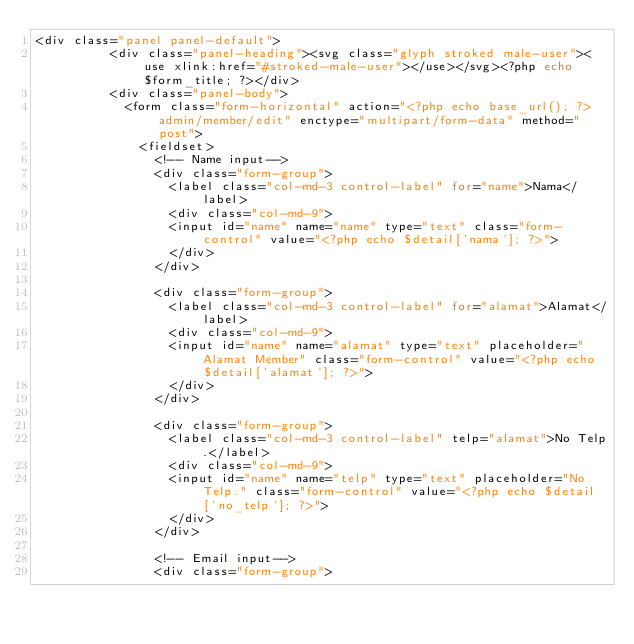Convert code to text. <code><loc_0><loc_0><loc_500><loc_500><_PHP_><div class="panel panel-default">
					<div class="panel-heading"><svg class="glyph stroked male-user"><use xlink:href="#stroked-male-user"></use></svg><?php echo $form_title; ?></div>
					<div class="panel-body">
						<form class="form-horizontal" action="<?php echo base_url(); ?>admin/member/edit" enctype="multipart/form-data" method="post">
							<fieldset>
								<!-- Name input-->
								<div class="form-group">
									<label class="col-md-3 control-label" for="name">Nama</label>
									<div class="col-md-9">
									<input id="name" name="name" type="text" class="form-control" value="<?php echo $detail['nama']; ?>">
									</div>
								</div>

								<div class="form-group">
									<label class="col-md-3 control-label" for="alamat">Alamat</label>
									<div class="col-md-9">
									<input id="name" name="alamat" type="text" placeholder="Alamat Member" class="form-control" value="<?php echo $detail['alamat']; ?>">
									</div>
								</div>

								<div class="form-group">
									<label class="col-md-3 control-label" telp="alamat">No Telp.</label>
									<div class="col-md-9">
									<input id="name" name="telp" type="text" placeholder="No Telp." class="form-control" value="<?php echo $detail['no_telp']; ?>">
									</div>
								</div>

								<!-- Email input-->
								<div class="form-group"></code> 